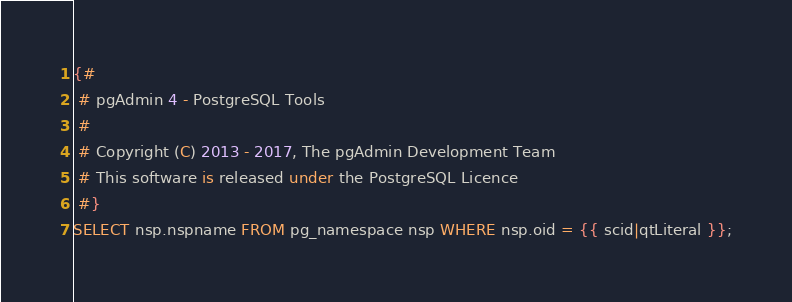<code> <loc_0><loc_0><loc_500><loc_500><_SQL_>{#
 # pgAdmin 4 - PostgreSQL Tools
 #
 # Copyright (C) 2013 - 2017, The pgAdmin Development Team
 # This software is released under the PostgreSQL Licence
 #}
SELECT nsp.nspname FROM pg_namespace nsp WHERE nsp.oid = {{ scid|qtLiteral }};
</code> 